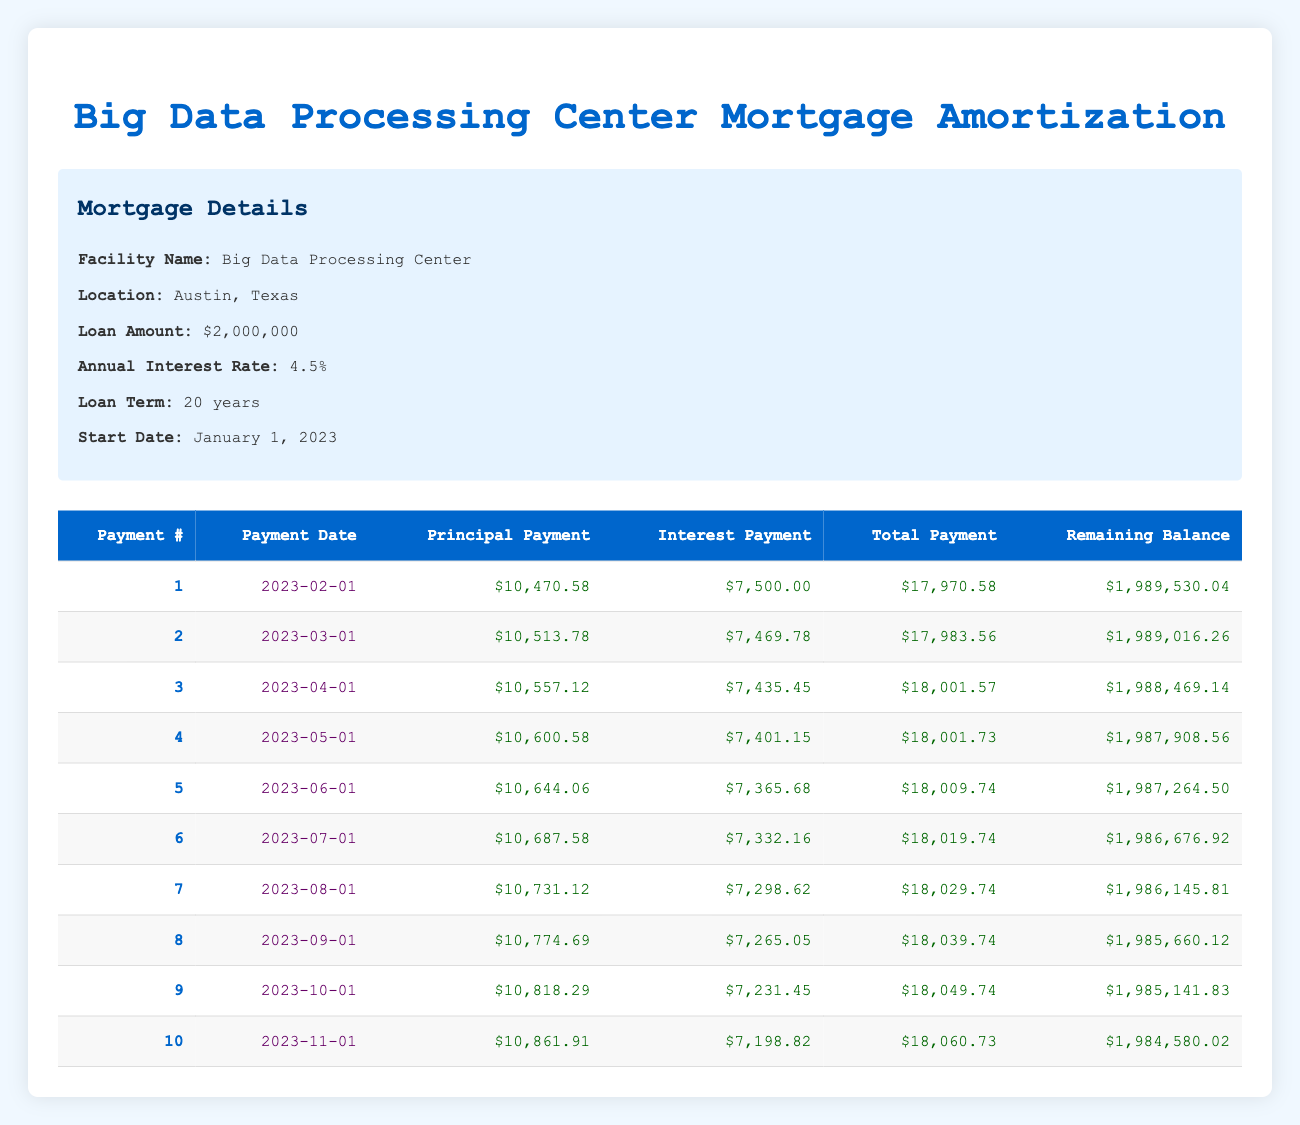What is the total payment for the first month? The total payment for the first month is listed in the table under the 'Total Payment' column for payment number 1, which is $17,970.58.
Answer: $17,970.58 What is the remaining balance after payment number 5? Looking at the table, the remaining balance after payment number 5 is shown in the 'Remaining Balance' column for payment number 5, which is $1,987,264.50.
Answer: $1,987,264.50 What is the total principal payment made in the first three months? The total principal payment in the first three months can be calculated by summing the principal payments from payments 1, 2, and 3: $10,470.58 + $10,513.78 + $10,557.12 = $31,541.48.
Answer: $31,541.48 Is the interest payment for payment number 4 greater than the interest payment for payment number 3? By comparing the interest payments listed in the table, the interest payment for payment number 4 is $7,401.15 and for payment number 3, it is $7,435.45. Since $7,401.15 is less than $7,435.45, the statement is false.
Answer: No What is the average total payment for the first ten payments? To find the average total payment, first sum the total payments for all ten payments: $17,970.58 + $17,983.56 + $18,001.57 + $18,001.73 + $18,009.74 + $18,019.74 + $18,029.74 + $18,039.74 + $18,049.74 + $18,060.73 = $180,004.56. Then, divide this sum by 10 to get the average: $180,004.56 / 10 = $18,000.46.
Answer: $18,000.46 How much total interest is paid in the first two months? The total interest paid in the first two months is the sum of the interest payments from payments 1 and 2: $7,500.00 + $7,469.78 = $14,969.78.
Answer: $14,969.78 Is the principal payment for payment number 7 the highest among the first ten payments? By examining the 'Principal Payment' column for payment number 7 which is $10,731.12, and comparing it with all previous payments, the highest principal payment in the first ten payments is actually $10,861.91 from payment number 10. Therefore, the statement is false.
Answer: No What is the difference between the total payment of payment number 10 and payment number 1? To find the difference, subtract the total payment of payment number 1 from that of payment number 10: $18,060.73 - $17,970.58 = $90.15.
Answer: $90.15 What is the interest payment in the seventh month? The interest payment in the seventh month can be found in the 'Interest Payment' column under payment number 7, which shows $7,298.62.
Answer: $7,298.62 